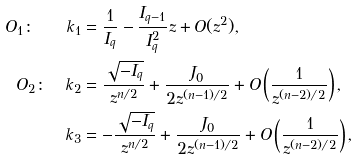Convert formula to latex. <formula><loc_0><loc_0><loc_500><loc_500>O _ { 1 } \colon \quad k _ { 1 } & = \frac { 1 } { I _ { q } } - \frac { I _ { q - 1 } } { I _ { q } ^ { 2 } } z + O ( z ^ { 2 } ) , \\ O _ { 2 } \colon \quad k _ { 2 } & = \frac { \sqrt { - I _ { q } } } { z ^ { n / 2 } } + \frac { J _ { 0 } } { 2 z ^ { ( n - 1 ) / 2 } } + O \left ( \frac { 1 } { z ^ { ( n - 2 ) / 2 } } \right ) , \\ k _ { 3 } & = - \frac { \sqrt { - I _ { q } } } { z ^ { n / 2 } } + \frac { J _ { 0 } } { 2 z ^ { ( n - 1 ) / 2 } } + O \left ( \frac { 1 } { z ^ { ( n - 2 ) / 2 } } \right ) ,</formula> 